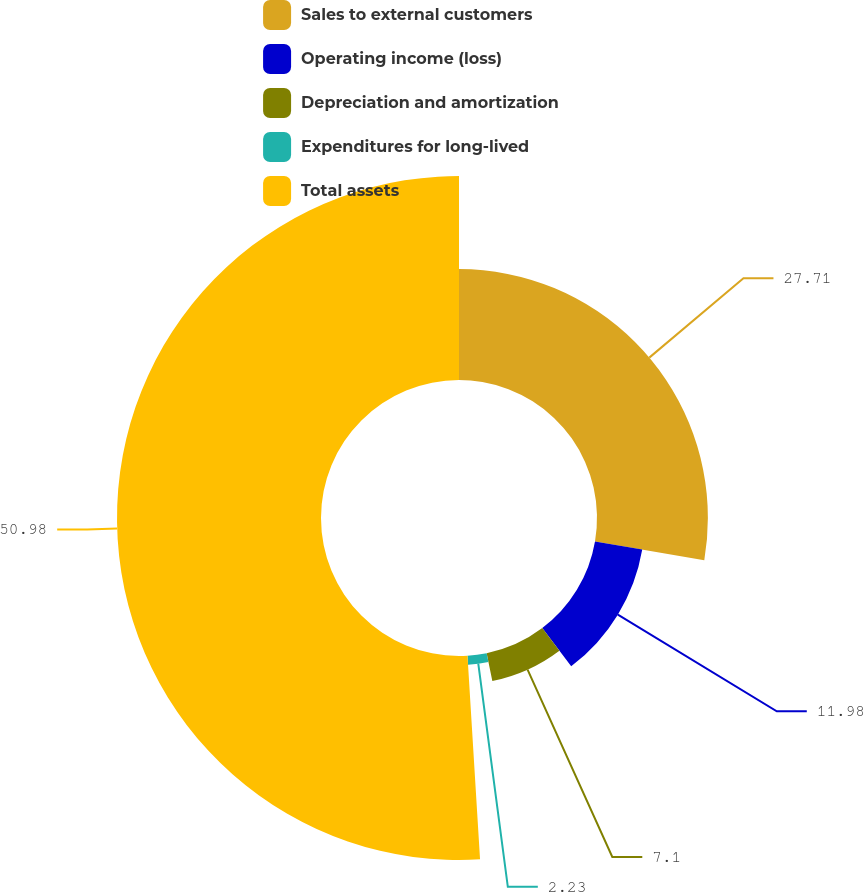Convert chart. <chart><loc_0><loc_0><loc_500><loc_500><pie_chart><fcel>Sales to external customers<fcel>Operating income (loss)<fcel>Depreciation and amortization<fcel>Expenditures for long-lived<fcel>Total assets<nl><fcel>27.71%<fcel>11.98%<fcel>7.1%<fcel>2.23%<fcel>50.98%<nl></chart> 